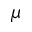Convert formula to latex. <formula><loc_0><loc_0><loc_500><loc_500>\mu</formula> 